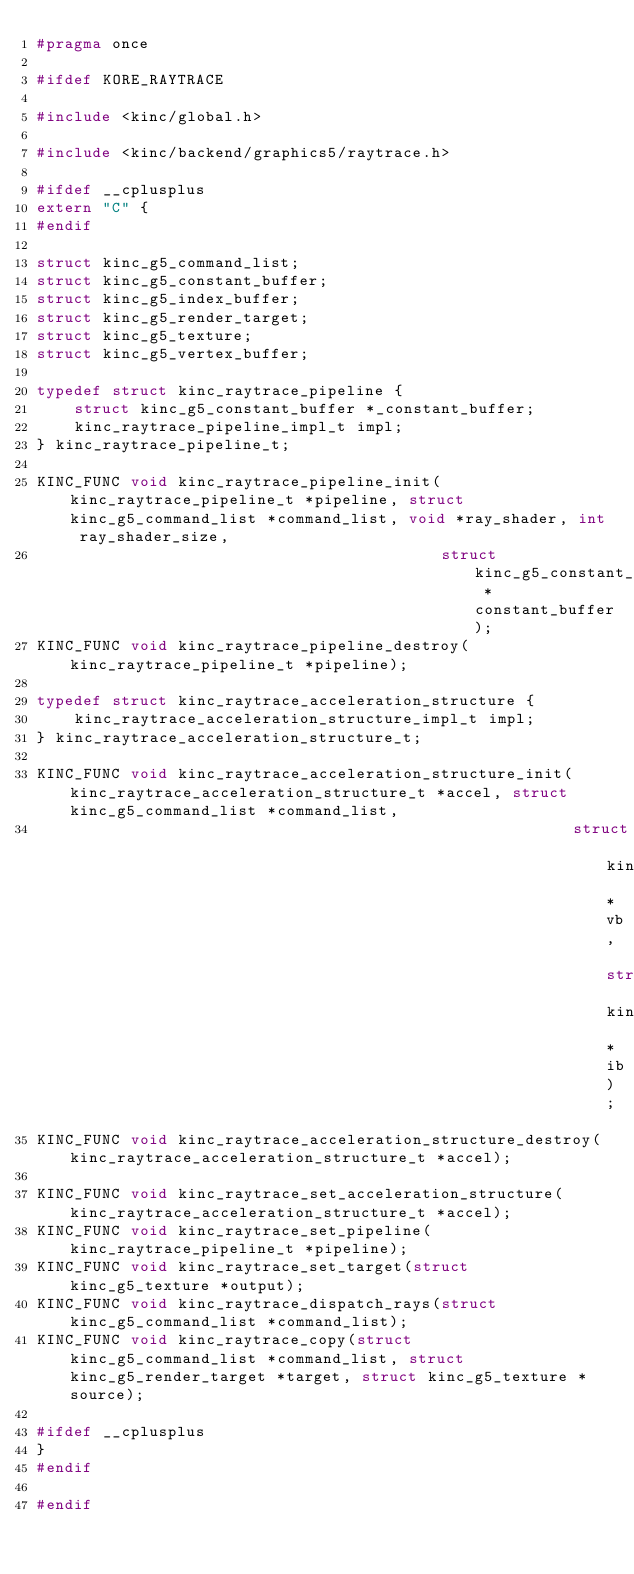Convert code to text. <code><loc_0><loc_0><loc_500><loc_500><_C_>#pragma once

#ifdef KORE_RAYTRACE

#include <kinc/global.h>

#include <kinc/backend/graphics5/raytrace.h>

#ifdef __cplusplus
extern "C" {
#endif

struct kinc_g5_command_list;
struct kinc_g5_constant_buffer;
struct kinc_g5_index_buffer;
struct kinc_g5_render_target;
struct kinc_g5_texture;
struct kinc_g5_vertex_buffer;

typedef struct kinc_raytrace_pipeline {
	struct kinc_g5_constant_buffer *_constant_buffer;
	kinc_raytrace_pipeline_impl_t impl;
} kinc_raytrace_pipeline_t;

KINC_FUNC void kinc_raytrace_pipeline_init(kinc_raytrace_pipeline_t *pipeline, struct kinc_g5_command_list *command_list, void *ray_shader, int ray_shader_size,
                                           struct kinc_g5_constant_buffer *constant_buffer);
KINC_FUNC void kinc_raytrace_pipeline_destroy(kinc_raytrace_pipeline_t *pipeline);

typedef struct kinc_raytrace_acceleration_structure {
	kinc_raytrace_acceleration_structure_impl_t impl;
} kinc_raytrace_acceleration_structure_t;

KINC_FUNC void kinc_raytrace_acceleration_structure_init(kinc_raytrace_acceleration_structure_t *accel, struct kinc_g5_command_list *command_list,
                                                         struct kinc_g5_vertex_buffer *vb, struct kinc_g5_index_buffer *ib);
KINC_FUNC void kinc_raytrace_acceleration_structure_destroy(kinc_raytrace_acceleration_structure_t *accel);

KINC_FUNC void kinc_raytrace_set_acceleration_structure(kinc_raytrace_acceleration_structure_t *accel);
KINC_FUNC void kinc_raytrace_set_pipeline(kinc_raytrace_pipeline_t *pipeline);
KINC_FUNC void kinc_raytrace_set_target(struct kinc_g5_texture *output);
KINC_FUNC void kinc_raytrace_dispatch_rays(struct kinc_g5_command_list *command_list);
KINC_FUNC void kinc_raytrace_copy(struct kinc_g5_command_list *command_list, struct kinc_g5_render_target *target, struct kinc_g5_texture *source);

#ifdef __cplusplus
}
#endif

#endif
</code> 